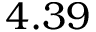Convert formula to latex. <formula><loc_0><loc_0><loc_500><loc_500>4 . 3 9</formula> 